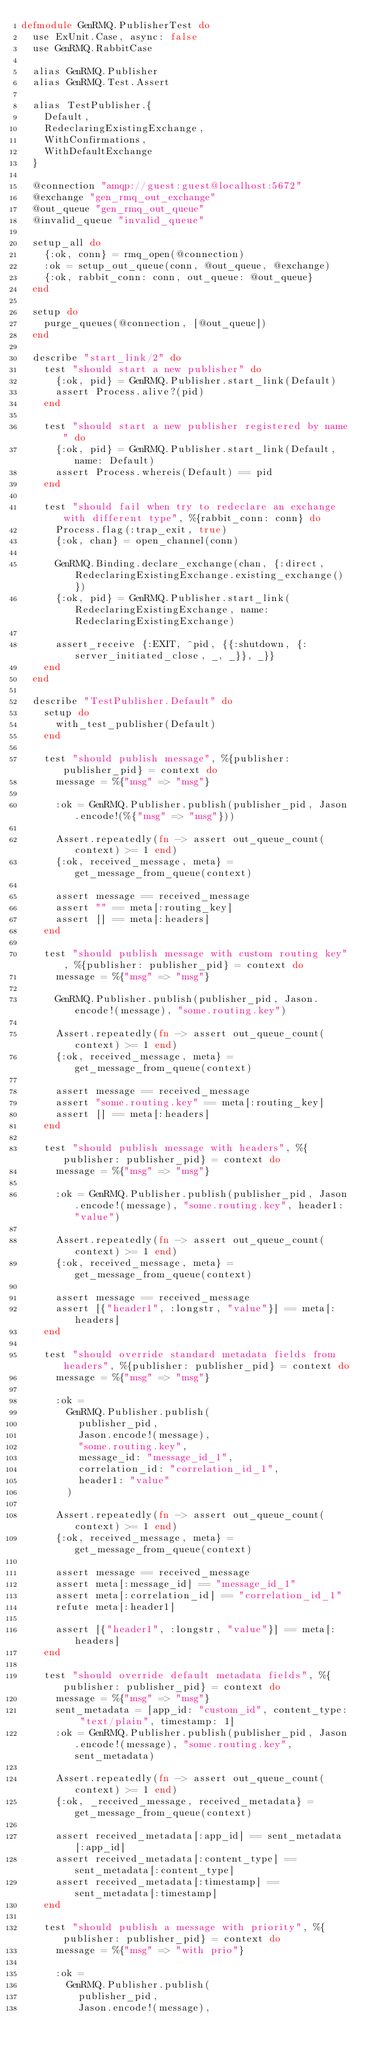<code> <loc_0><loc_0><loc_500><loc_500><_Elixir_>defmodule GenRMQ.PublisherTest do
  use ExUnit.Case, async: false
  use GenRMQ.RabbitCase

  alias GenRMQ.Publisher
  alias GenRMQ.Test.Assert

  alias TestPublisher.{
    Default,
    RedeclaringExistingExchange,
    WithConfirmations,
    WithDefaultExchange
  }

  @connection "amqp://guest:guest@localhost:5672"
  @exchange "gen_rmq_out_exchange"
  @out_queue "gen_rmq_out_queue"
  @invalid_queue "invalid_queue"

  setup_all do
    {:ok, conn} = rmq_open(@connection)
    :ok = setup_out_queue(conn, @out_queue, @exchange)
    {:ok, rabbit_conn: conn, out_queue: @out_queue}
  end

  setup do
    purge_queues(@connection, [@out_queue])
  end

  describe "start_link/2" do
    test "should start a new publisher" do
      {:ok, pid} = GenRMQ.Publisher.start_link(Default)
      assert Process.alive?(pid)
    end

    test "should start a new publisher registered by name" do
      {:ok, pid} = GenRMQ.Publisher.start_link(Default, name: Default)
      assert Process.whereis(Default) == pid
    end

    test "should fail when try to redeclare an exchange with different type", %{rabbit_conn: conn} do
      Process.flag(:trap_exit, true)
      {:ok, chan} = open_channel(conn)

      GenRMQ.Binding.declare_exchange(chan, {:direct, RedeclaringExistingExchange.existing_exchange()})
      {:ok, pid} = GenRMQ.Publisher.start_link(RedeclaringExistingExchange, name: RedeclaringExistingExchange)

      assert_receive {:EXIT, ^pid, {{:shutdown, {:server_initiated_close, _, _}}, _}}
    end
  end

  describe "TestPublisher.Default" do
    setup do
      with_test_publisher(Default)
    end

    test "should publish message", %{publisher: publisher_pid} = context do
      message = %{"msg" => "msg"}

      :ok = GenRMQ.Publisher.publish(publisher_pid, Jason.encode!(%{"msg" => "msg"}))

      Assert.repeatedly(fn -> assert out_queue_count(context) >= 1 end)
      {:ok, received_message, meta} = get_message_from_queue(context)

      assert message == received_message
      assert "" == meta[:routing_key]
      assert [] == meta[:headers]
    end

    test "should publish message with custom routing key", %{publisher: publisher_pid} = context do
      message = %{"msg" => "msg"}

      GenRMQ.Publisher.publish(publisher_pid, Jason.encode!(message), "some.routing.key")

      Assert.repeatedly(fn -> assert out_queue_count(context) >= 1 end)
      {:ok, received_message, meta} = get_message_from_queue(context)

      assert message == received_message
      assert "some.routing.key" == meta[:routing_key]
      assert [] == meta[:headers]
    end

    test "should publish message with headers", %{publisher: publisher_pid} = context do
      message = %{"msg" => "msg"}

      :ok = GenRMQ.Publisher.publish(publisher_pid, Jason.encode!(message), "some.routing.key", header1: "value")

      Assert.repeatedly(fn -> assert out_queue_count(context) >= 1 end)
      {:ok, received_message, meta} = get_message_from_queue(context)

      assert message == received_message
      assert [{"header1", :longstr, "value"}] == meta[:headers]
    end

    test "should override standard metadata fields from headers", %{publisher: publisher_pid} = context do
      message = %{"msg" => "msg"}

      :ok =
        GenRMQ.Publisher.publish(
          publisher_pid,
          Jason.encode!(message),
          "some.routing.key",
          message_id: "message_id_1",
          correlation_id: "correlation_id_1",
          header1: "value"
        )

      Assert.repeatedly(fn -> assert out_queue_count(context) >= 1 end)
      {:ok, received_message, meta} = get_message_from_queue(context)

      assert message == received_message
      assert meta[:message_id] == "message_id_1"
      assert meta[:correlation_id] == "correlation_id_1"
      refute meta[:header1]

      assert [{"header1", :longstr, "value"}] == meta[:headers]
    end

    test "should override default metadata fields", %{publisher: publisher_pid} = context do
      message = %{"msg" => "msg"}
      sent_metadata = [app_id: "custom_id", content_type: "text/plain", timestamp: 1]
      :ok = GenRMQ.Publisher.publish(publisher_pid, Jason.encode!(message), "some.routing.key", sent_metadata)

      Assert.repeatedly(fn -> assert out_queue_count(context) >= 1 end)
      {:ok, _received_message, received_metadata} = get_message_from_queue(context)

      assert received_metadata[:app_id] == sent_metadata[:app_id]
      assert received_metadata[:content_type] == sent_metadata[:content_type]
      assert received_metadata[:timestamp] == sent_metadata[:timestamp]
    end

    test "should publish a message with priority", %{publisher: publisher_pid} = context do
      message = %{"msg" => "with prio"}

      :ok =
        GenRMQ.Publisher.publish(
          publisher_pid,
          Jason.encode!(message),</code> 